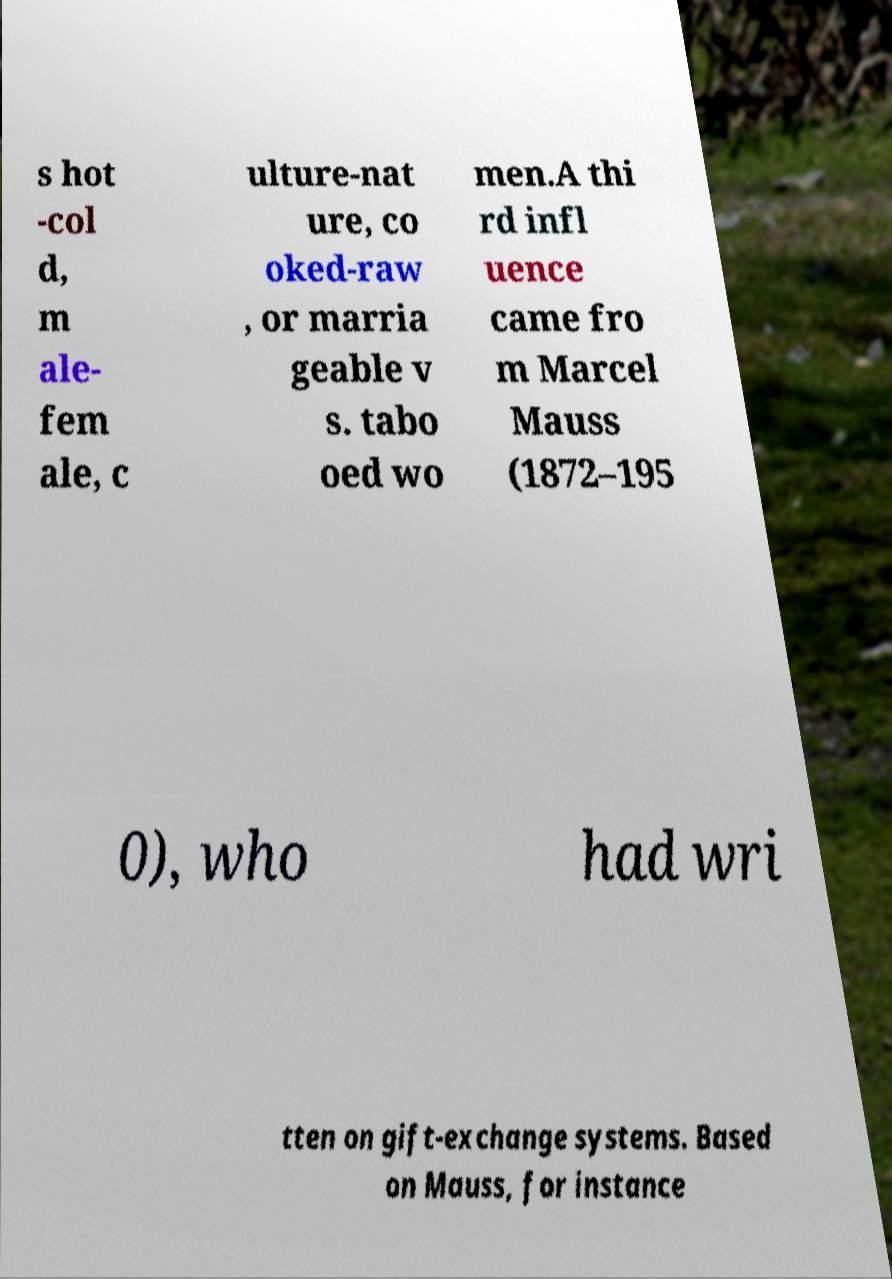What messages or text are displayed in this image? I need them in a readable, typed format. s hot -col d, m ale- fem ale, c ulture-nat ure, co oked-raw , or marria geable v s. tabo oed wo men.A thi rd infl uence came fro m Marcel Mauss (1872–195 0), who had wri tten on gift-exchange systems. Based on Mauss, for instance 